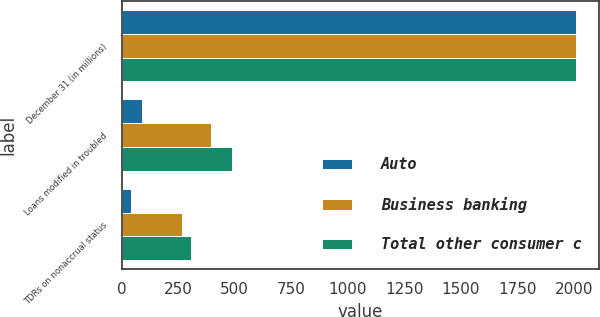Convert chart. <chart><loc_0><loc_0><loc_500><loc_500><stacked_bar_chart><ecel><fcel>December 31 (in millions)<fcel>Loans modified in troubled<fcel>TDRs on nonaccrual status<nl><fcel>Auto<fcel>2010<fcel>91<fcel>39<nl><fcel>Business banking<fcel>2010<fcel>395<fcel>268<nl><fcel>Total other consumer c<fcel>2010<fcel>486<fcel>307<nl></chart> 